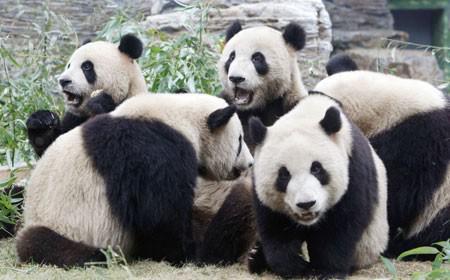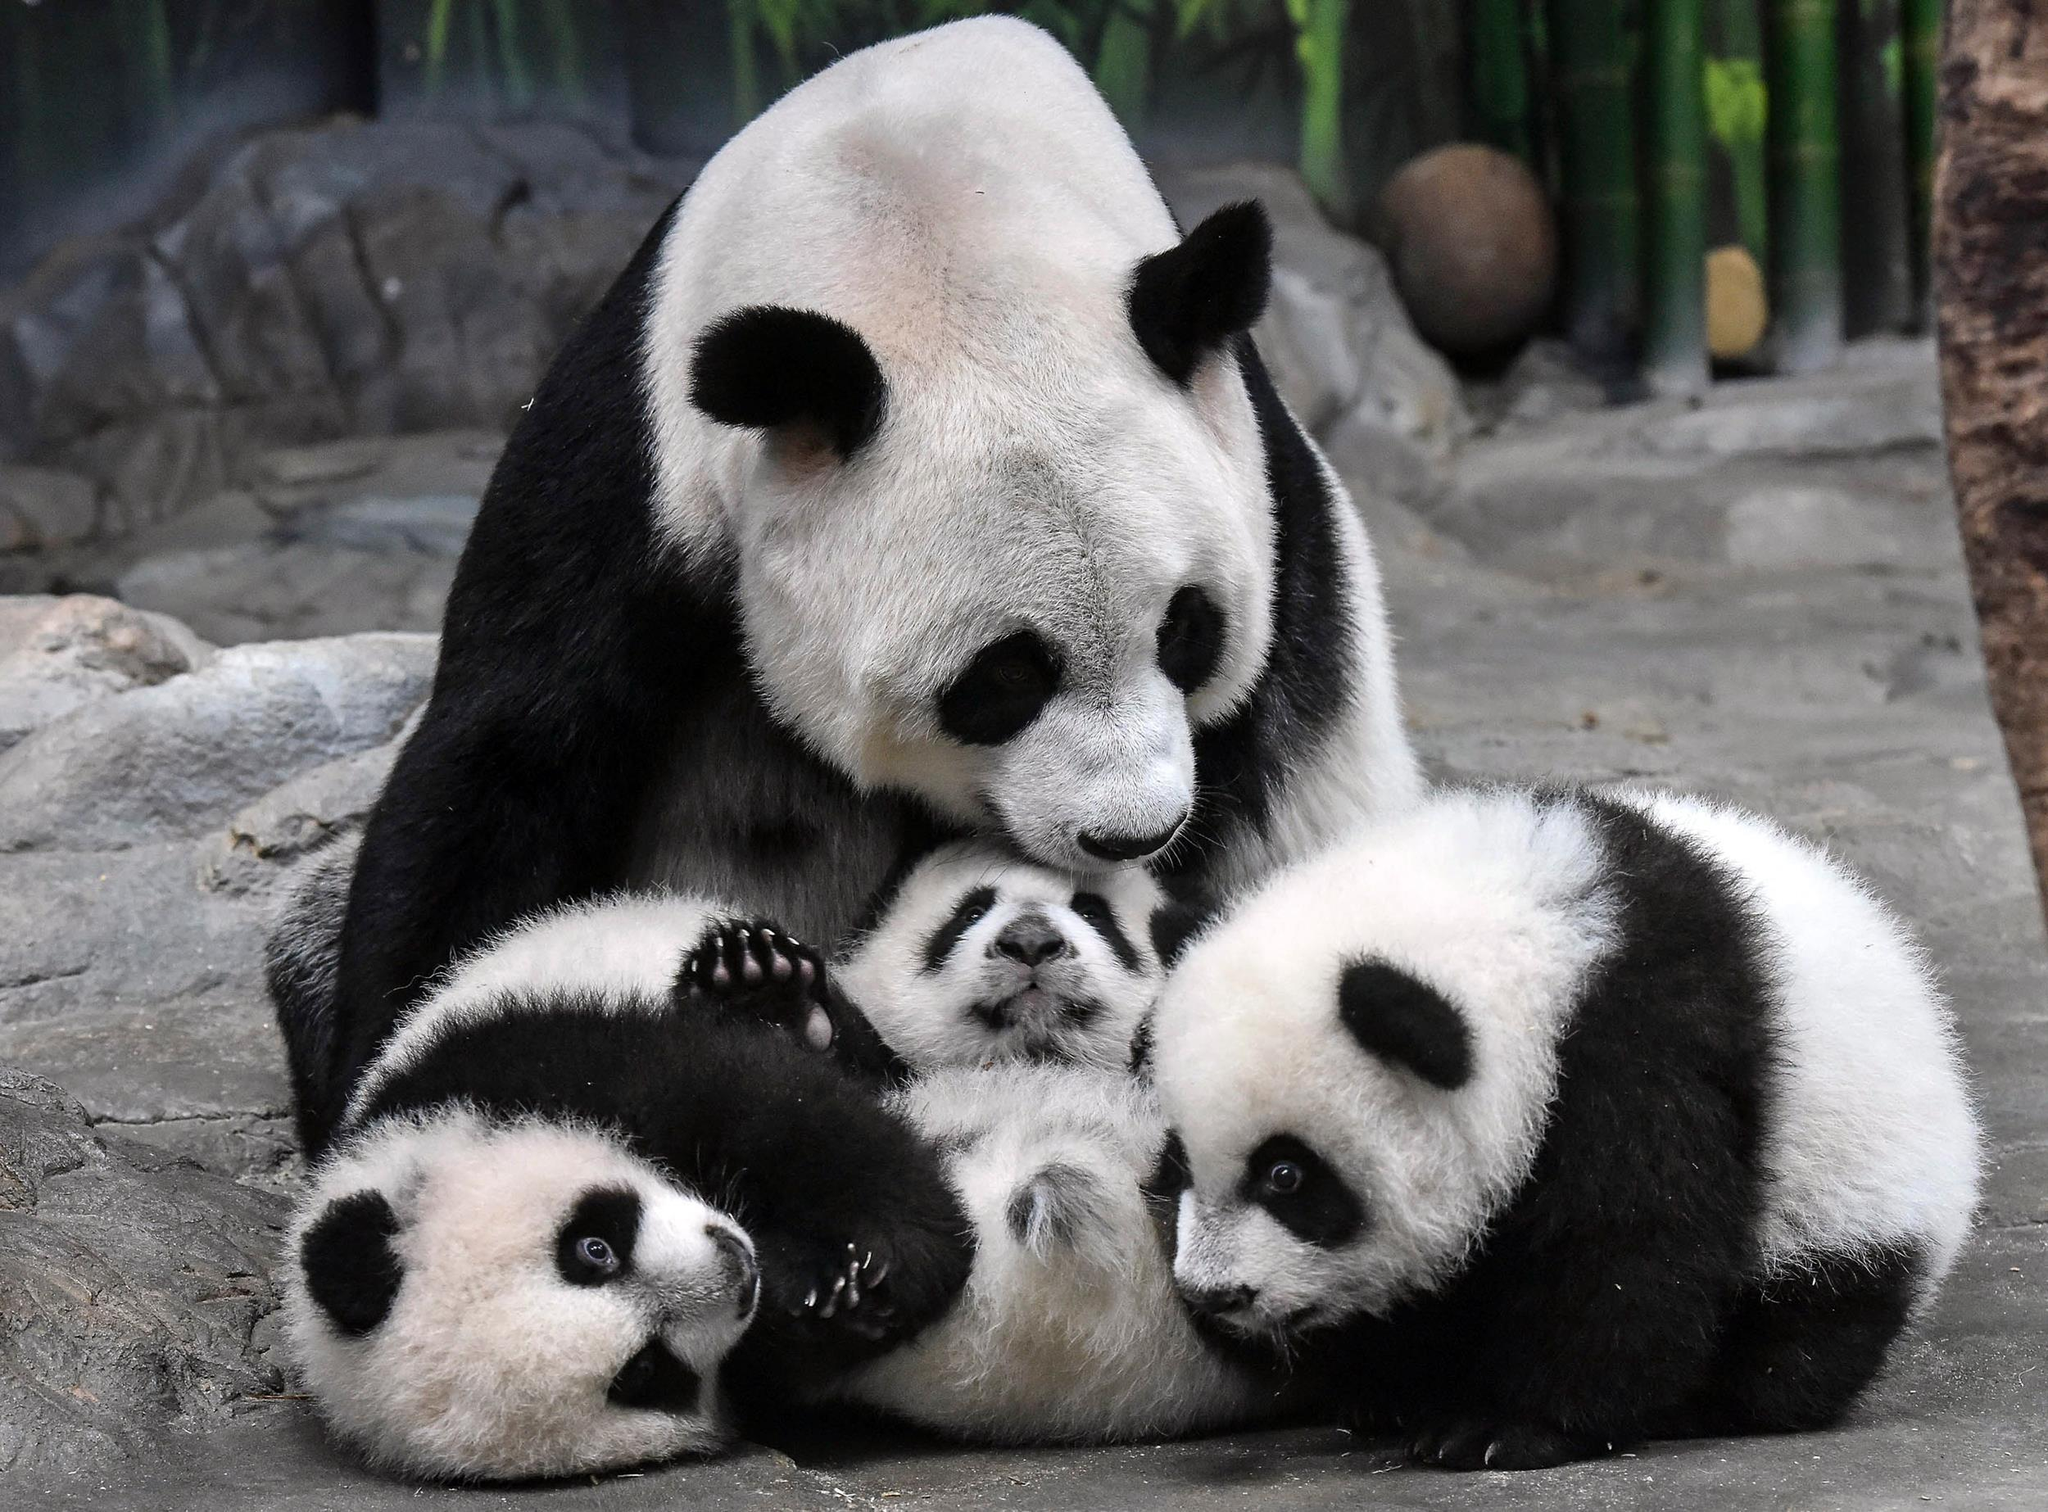The first image is the image on the left, the second image is the image on the right. Assess this claim about the two images: "There are exactly three pandas in the right image.". Correct or not? Answer yes or no. No. 